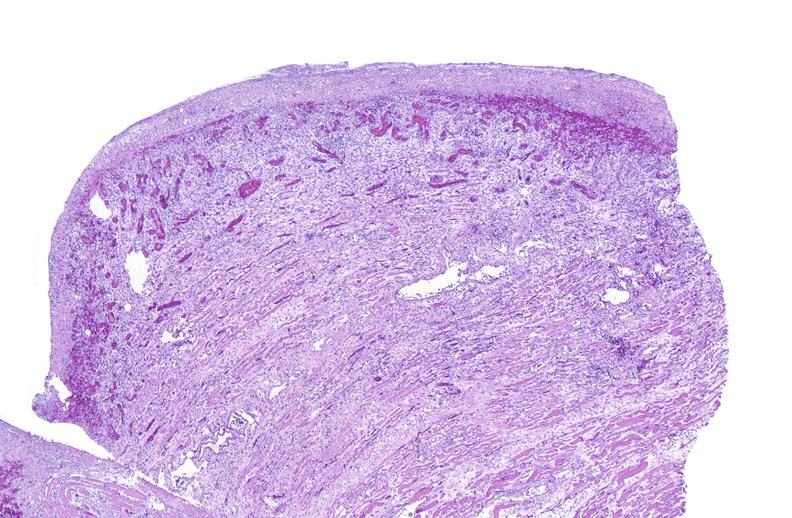s miliary tuberculosis present?
Answer the question using a single word or phrase. No 